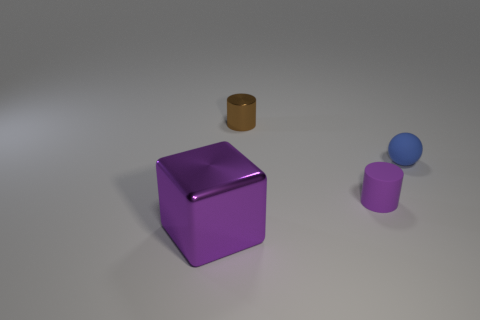How does the arrangement of objects affect the composition of the image? The arrangement of objects creates a balanced yet dynamic composition. The large purple cube dominates the visual space, creating a strong focal point due to its size and central positioning. The smaller objects are placed to the right, creating a sense of asymmetry and movement as the eye travels from the larger to the smaller items. The spacing between the objects ensures each item is distinct, yet they relate to each other within the same context, contributing to a cohesive scene. 